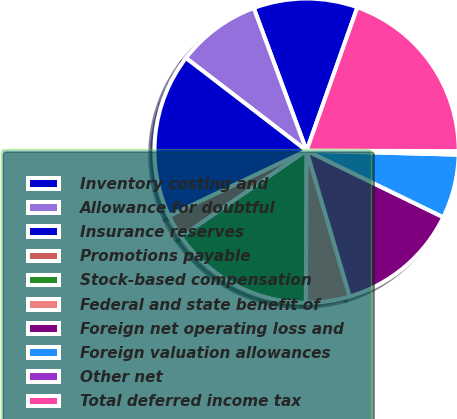Convert chart to OTSL. <chart><loc_0><loc_0><loc_500><loc_500><pie_chart><fcel>Inventory costing and<fcel>Allowance for doubtful<fcel>Insurance reserves<fcel>Promotions payable<fcel>Stock-based compensation<fcel>Federal and state benefit of<fcel>Foreign net operating loss and<fcel>Foreign valuation allowances<fcel>Other net<fcel>Total deferred income tax<nl><fcel>11.07%<fcel>8.93%<fcel>17.49%<fcel>2.51%<fcel>15.35%<fcel>4.65%<fcel>13.21%<fcel>6.79%<fcel>0.37%<fcel>19.63%<nl></chart> 